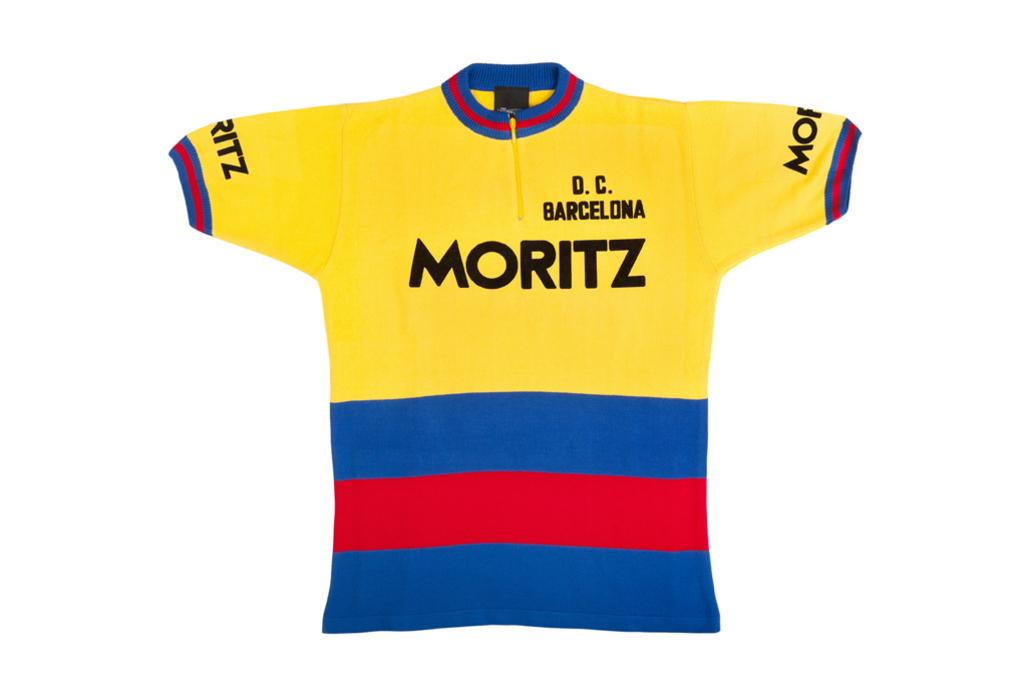<image>
Present a compact description of the photo's key features. a jersey that has the word Moritz on it 